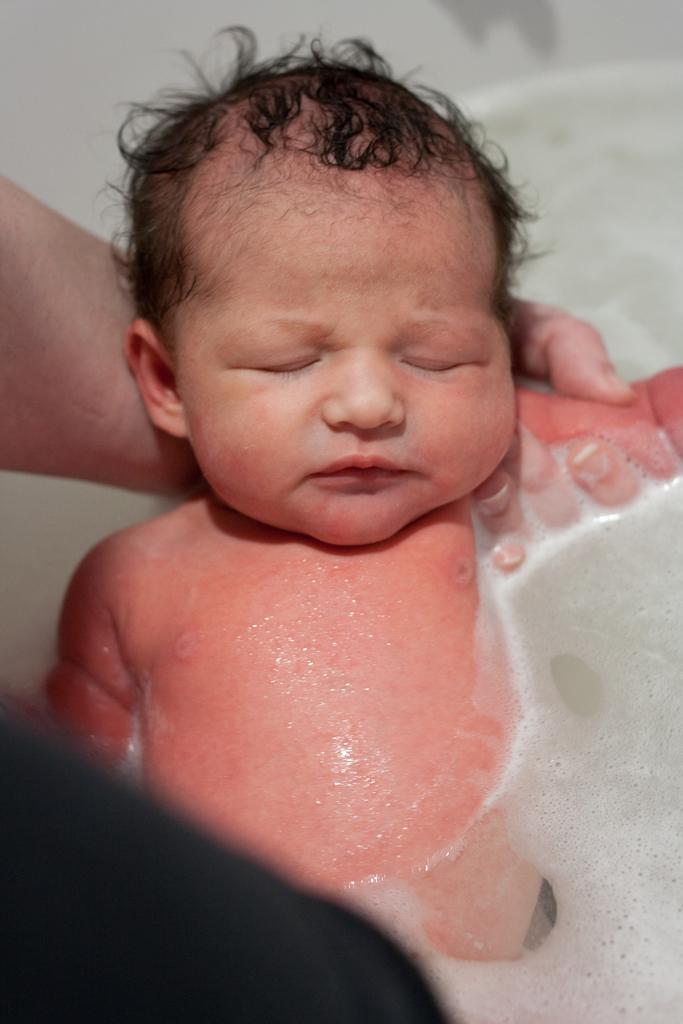In one or two sentences, can you explain what this image depicts? In this image there is one baby who is in water, and one person is holding the baby. And there is some water on the right side of the image, at the bottom there is a shadow is visible. 